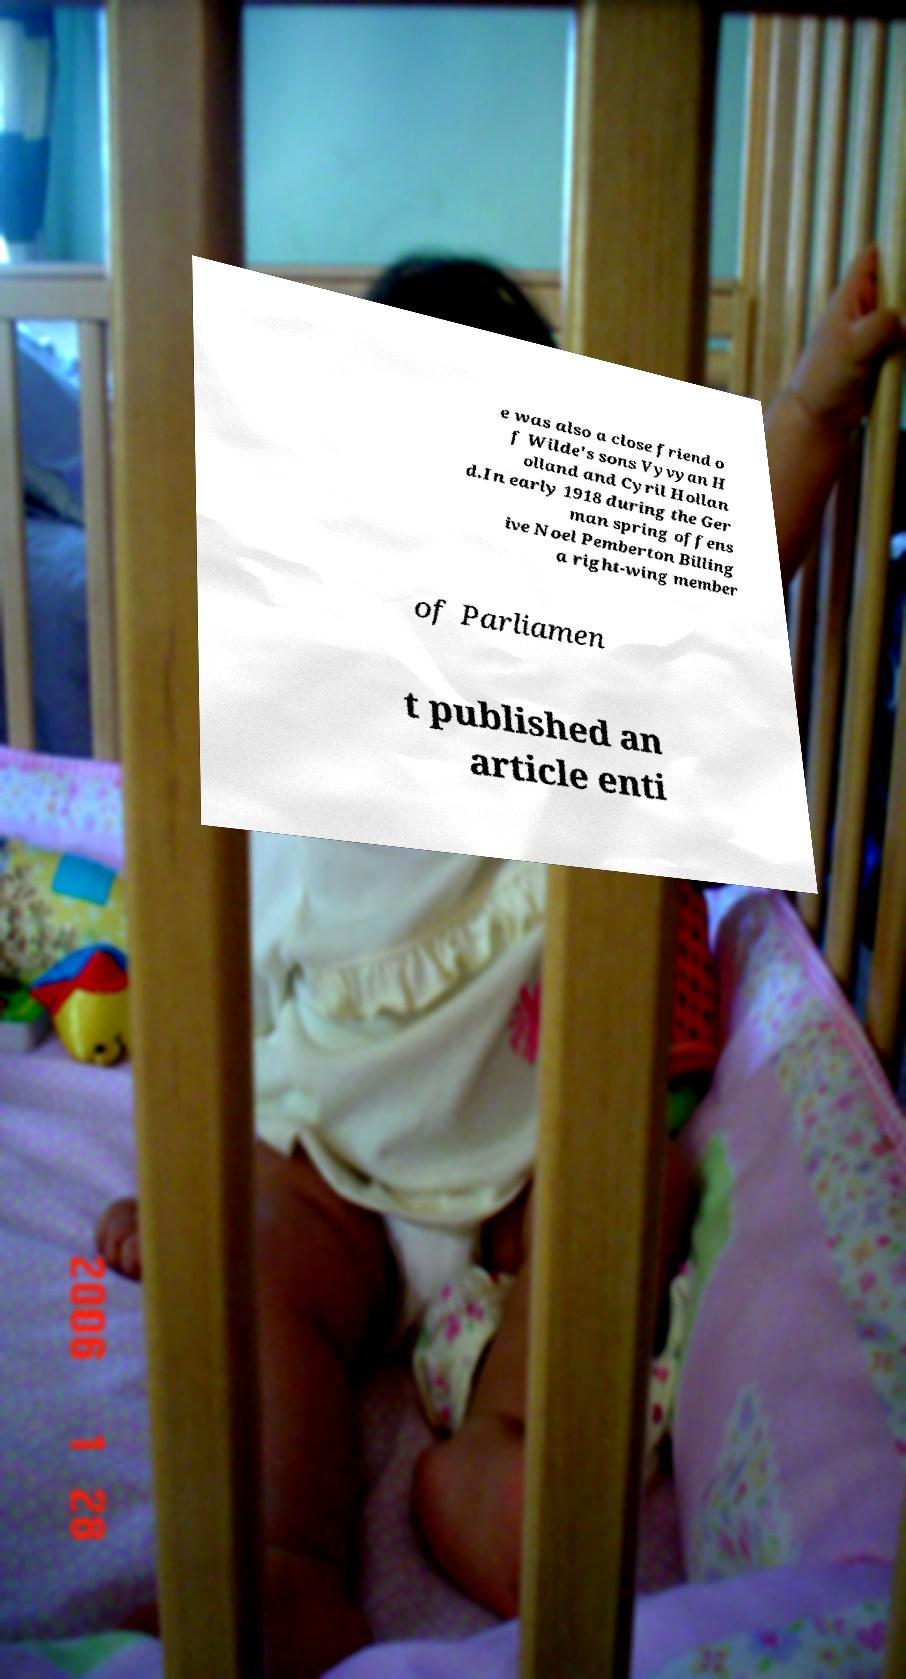Could you assist in decoding the text presented in this image and type it out clearly? e was also a close friend o f Wilde's sons Vyvyan H olland and Cyril Hollan d.In early 1918 during the Ger man spring offens ive Noel Pemberton Billing a right-wing member of Parliamen t published an article enti 